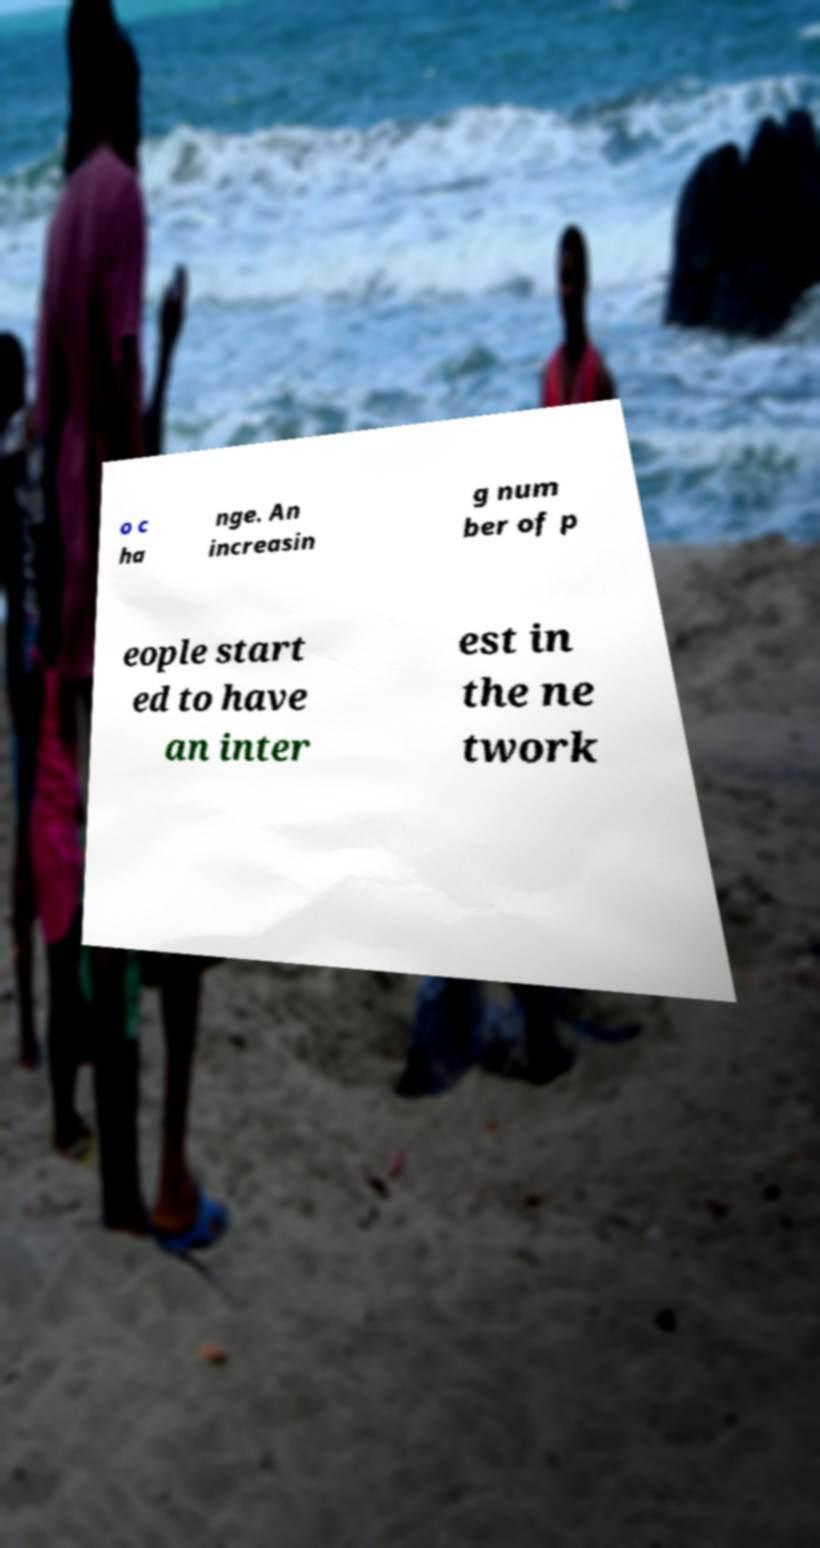Could you extract and type out the text from this image? o c ha nge. An increasin g num ber of p eople start ed to have an inter est in the ne twork 